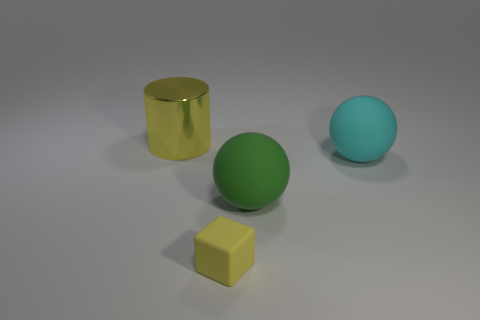Does the thing on the left side of the tiny block have the same color as the matte object that is to the left of the big green matte object?
Provide a succinct answer. Yes. Is the big green object the same shape as the large cyan matte thing?
Offer a terse response. Yes. There is a large green thing that is the same shape as the large cyan thing; what is its material?
Offer a terse response. Rubber. What number of matte things have the same color as the big metal thing?
Provide a short and direct response. 1. Is there a purple block of the same size as the green rubber object?
Your answer should be very brief. No. There is a cyan thing that is the same size as the yellow shiny cylinder; what is its material?
Your response must be concise. Rubber. What number of big cyan matte objects are there?
Offer a very short reply. 1. There is a yellow rubber thing on the left side of the big cyan matte sphere; what is its size?
Offer a terse response. Small. Is the number of objects that are in front of the large cyan object the same as the number of big balls?
Ensure brevity in your answer.  Yes. Is there a large cyan matte object of the same shape as the large green matte object?
Your answer should be compact. Yes. 